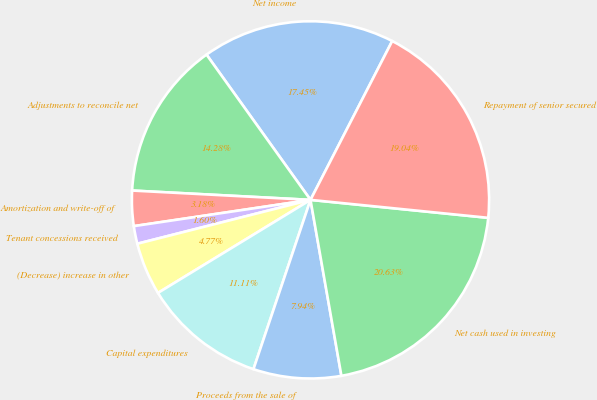Convert chart. <chart><loc_0><loc_0><loc_500><loc_500><pie_chart><fcel>Net income<fcel>Adjustments to reconcile net<fcel>Amortization and write-off of<fcel>Tenant concessions received<fcel>(Decrease) increase in other<fcel>Capital expenditures<fcel>Proceeds from the sale of<fcel>Net cash used in investing<fcel>Repayment of senior secured<nl><fcel>17.45%<fcel>14.28%<fcel>3.18%<fcel>1.6%<fcel>4.77%<fcel>11.11%<fcel>7.94%<fcel>20.63%<fcel>19.04%<nl></chart> 